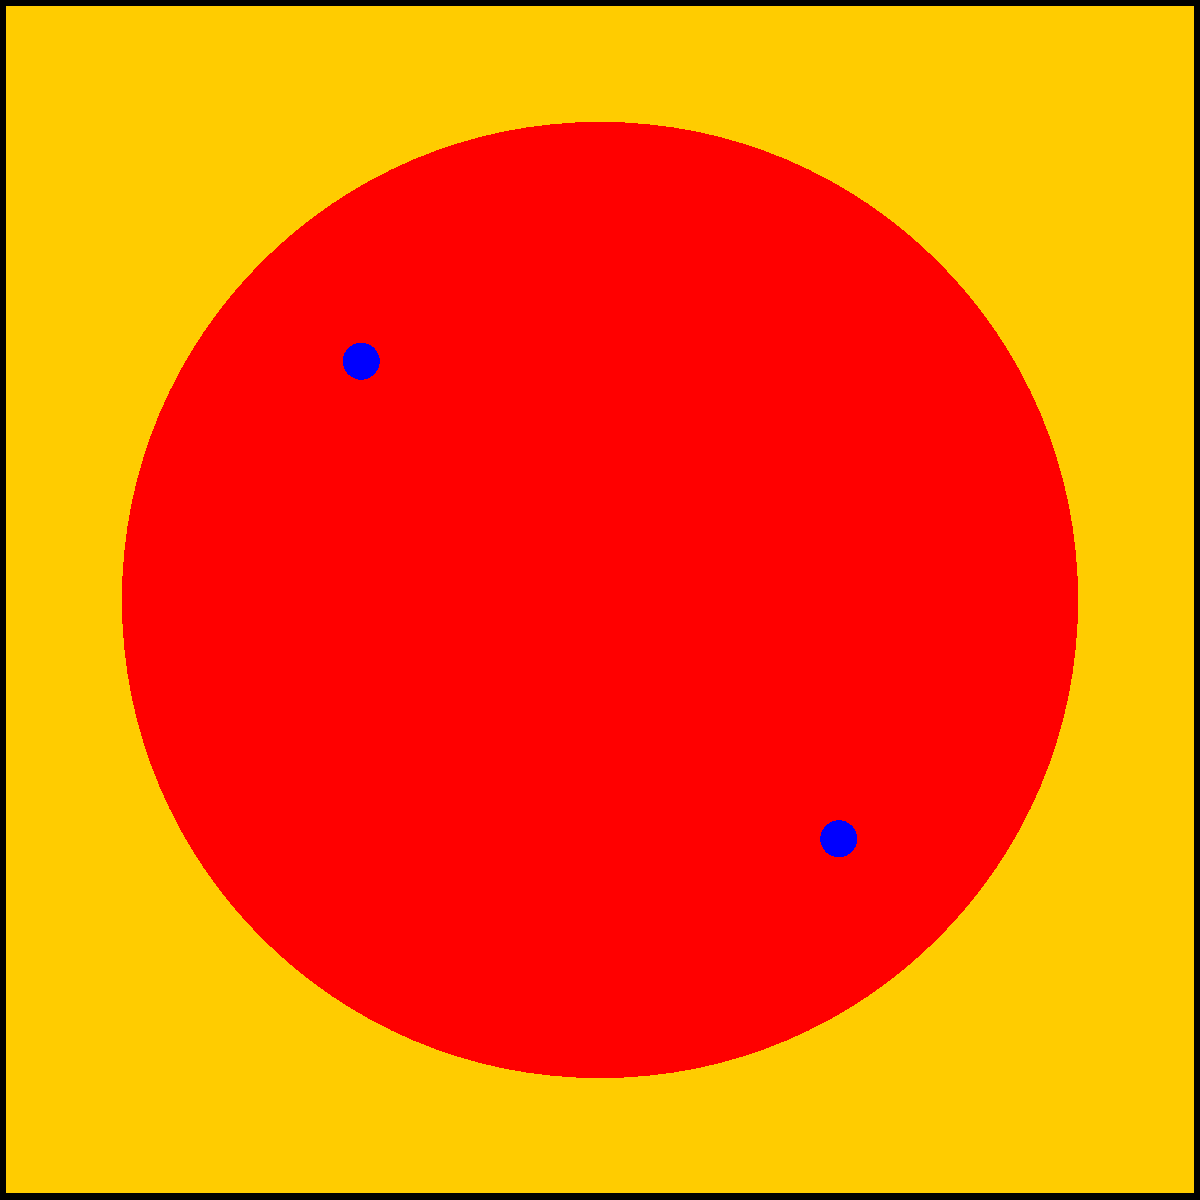Which iconic pop art artist is most likely associated with the simplified graphic representation shown above? To identify the iconic pop art artist associated with this simplified graphic, let's analyze the key elements:

1. Bold, flat colors: The image uses a bright yellow background with a large red circle, characteristic of pop art's vibrant color palette.

2. Simple geometric shapes: The composition consists of a square background, a circle, and dots, reflecting pop art's tendency to use basic shapes.

3. Comic book style: The use of primary colors (red, yellow, blue) and the dot pattern resembles the Ben-Day dots used in comic book printing, a technique often employed in pop art.

4. Repetition and pattern: The two blue dots create a sense of pattern, a common feature in pop art.

5. High contrast: The red circle against the yellow background creates a striking visual contrast, typical of pop art's eye-catching designs.

These elements, particularly the use of Ben-Day dots and bold, flat colors in a simplified composition, are hallmarks of Roy Lichtenstein's pop art style. Lichtenstein was known for appropriating images from comic books and advertisements, transforming them into large-scale paintings that emphasized the mechanical nature of mass-produced imagery.

While other pop artists like Andy Warhol also used bold colors and simple shapes, the specific combination of elements in this graphic, especially the dot pattern, is most closely associated with Lichtenstein's work.
Answer: Roy Lichtenstein 